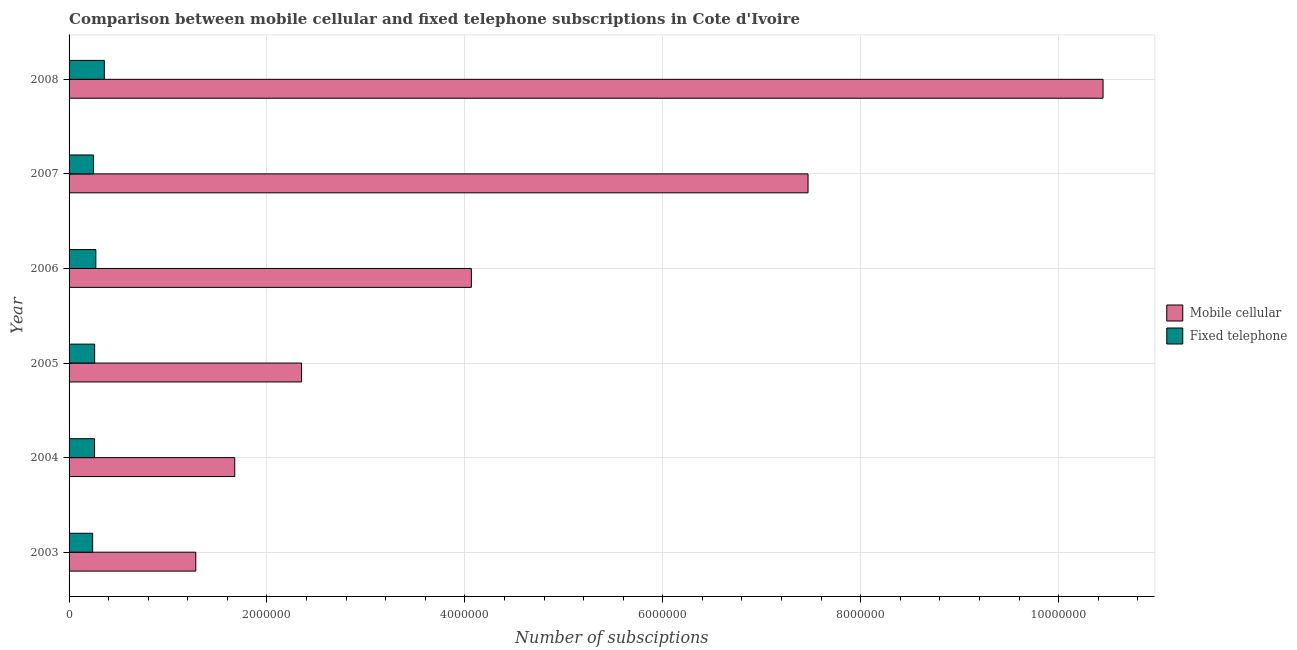How many groups of bars are there?
Give a very brief answer. 6. Are the number of bars per tick equal to the number of legend labels?
Your response must be concise. Yes. Are the number of bars on each tick of the Y-axis equal?
Offer a very short reply. Yes. How many bars are there on the 3rd tick from the top?
Provide a succinct answer. 2. How many bars are there on the 3rd tick from the bottom?
Give a very brief answer. 2. What is the number of mobile cellular subscriptions in 2004?
Make the answer very short. 1.67e+06. Across all years, what is the maximum number of fixed telephone subscriptions?
Offer a very short reply. 3.57e+05. Across all years, what is the minimum number of mobile cellular subscriptions?
Your answer should be compact. 1.28e+06. In which year was the number of fixed telephone subscriptions maximum?
Keep it short and to the point. 2008. What is the total number of fixed telephone subscriptions in the graph?
Offer a terse response. 1.63e+06. What is the difference between the number of mobile cellular subscriptions in 2007 and that in 2008?
Keep it short and to the point. -2.98e+06. What is the difference between the number of mobile cellular subscriptions in 2007 and the number of fixed telephone subscriptions in 2005?
Provide a succinct answer. 7.21e+06. What is the average number of fixed telephone subscriptions per year?
Ensure brevity in your answer.  2.72e+05. In the year 2008, what is the difference between the number of mobile cellular subscriptions and number of fixed telephone subscriptions?
Offer a very short reply. 1.01e+07. In how many years, is the number of mobile cellular subscriptions greater than 2400000 ?
Provide a short and direct response. 3. What is the ratio of the number of fixed telephone subscriptions in 2006 to that in 2007?
Your answer should be compact. 1.09. Is the number of fixed telephone subscriptions in 2006 less than that in 2007?
Give a very brief answer. No. What is the difference between the highest and the second highest number of mobile cellular subscriptions?
Provide a short and direct response. 2.98e+06. What is the difference between the highest and the lowest number of fixed telephone subscriptions?
Offer a very short reply. 1.19e+05. What does the 1st bar from the top in 2003 represents?
Make the answer very short. Fixed telephone. What does the 2nd bar from the bottom in 2008 represents?
Provide a short and direct response. Fixed telephone. How many bars are there?
Provide a succinct answer. 12. Are all the bars in the graph horizontal?
Offer a very short reply. Yes. How many years are there in the graph?
Your answer should be very brief. 6. Are the values on the major ticks of X-axis written in scientific E-notation?
Your answer should be very brief. No. Does the graph contain any zero values?
Your answer should be compact. No. How many legend labels are there?
Ensure brevity in your answer.  2. How are the legend labels stacked?
Your response must be concise. Vertical. What is the title of the graph?
Provide a succinct answer. Comparison between mobile cellular and fixed telephone subscriptions in Cote d'Ivoire. What is the label or title of the X-axis?
Offer a terse response. Number of subsciptions. What is the Number of subsciptions of Mobile cellular in 2003?
Provide a succinct answer. 1.28e+06. What is the Number of subsciptions of Fixed telephone in 2003?
Provide a short and direct response. 2.38e+05. What is the Number of subsciptions in Mobile cellular in 2004?
Your answer should be compact. 1.67e+06. What is the Number of subsciptions of Fixed telephone in 2004?
Provide a succinct answer. 2.58e+05. What is the Number of subsciptions in Mobile cellular in 2005?
Your answer should be compact. 2.35e+06. What is the Number of subsciptions of Fixed telephone in 2005?
Make the answer very short. 2.59e+05. What is the Number of subsciptions in Mobile cellular in 2006?
Offer a terse response. 4.07e+06. What is the Number of subsciptions in Fixed telephone in 2006?
Make the answer very short. 2.71e+05. What is the Number of subsciptions in Mobile cellular in 2007?
Offer a terse response. 7.47e+06. What is the Number of subsciptions in Fixed telephone in 2007?
Offer a terse response. 2.48e+05. What is the Number of subsciptions in Mobile cellular in 2008?
Provide a succinct answer. 1.04e+07. What is the Number of subsciptions in Fixed telephone in 2008?
Your answer should be compact. 3.57e+05. Across all years, what is the maximum Number of subsciptions of Mobile cellular?
Offer a terse response. 1.04e+07. Across all years, what is the maximum Number of subsciptions of Fixed telephone?
Give a very brief answer. 3.57e+05. Across all years, what is the minimum Number of subsciptions in Mobile cellular?
Give a very brief answer. 1.28e+06. Across all years, what is the minimum Number of subsciptions in Fixed telephone?
Offer a very short reply. 2.38e+05. What is the total Number of subsciptions of Mobile cellular in the graph?
Offer a very short reply. 2.73e+07. What is the total Number of subsciptions of Fixed telephone in the graph?
Your answer should be compact. 1.63e+06. What is the difference between the Number of subsciptions of Mobile cellular in 2003 and that in 2004?
Give a very brief answer. -3.94e+05. What is the difference between the Number of subsciptions in Fixed telephone in 2003 and that in 2004?
Your answer should be compact. -1.99e+04. What is the difference between the Number of subsciptions of Mobile cellular in 2003 and that in 2005?
Your answer should be very brief. -1.07e+06. What is the difference between the Number of subsciptions of Fixed telephone in 2003 and that in 2005?
Ensure brevity in your answer.  -2.05e+04. What is the difference between the Number of subsciptions of Mobile cellular in 2003 and that in 2006?
Offer a very short reply. -2.78e+06. What is the difference between the Number of subsciptions in Fixed telephone in 2003 and that in 2006?
Offer a very short reply. -3.26e+04. What is the difference between the Number of subsciptions of Mobile cellular in 2003 and that in 2007?
Make the answer very short. -6.19e+06. What is the difference between the Number of subsciptions in Fixed telephone in 2003 and that in 2007?
Your response must be concise. -9573. What is the difference between the Number of subsciptions in Mobile cellular in 2003 and that in 2008?
Offer a terse response. -9.17e+06. What is the difference between the Number of subsciptions of Fixed telephone in 2003 and that in 2008?
Provide a short and direct response. -1.19e+05. What is the difference between the Number of subsciptions of Mobile cellular in 2004 and that in 2005?
Offer a very short reply. -6.75e+05. What is the difference between the Number of subsciptions of Fixed telephone in 2004 and that in 2005?
Provide a succinct answer. -583. What is the difference between the Number of subsciptions in Mobile cellular in 2004 and that in 2006?
Provide a short and direct response. -2.39e+06. What is the difference between the Number of subsciptions of Fixed telephone in 2004 and that in 2006?
Give a very brief answer. -1.26e+04. What is the difference between the Number of subsciptions in Mobile cellular in 2004 and that in 2007?
Ensure brevity in your answer.  -5.79e+06. What is the difference between the Number of subsciptions in Fixed telephone in 2004 and that in 2007?
Ensure brevity in your answer.  1.04e+04. What is the difference between the Number of subsciptions in Mobile cellular in 2004 and that in 2008?
Your answer should be very brief. -8.77e+06. What is the difference between the Number of subsciptions in Fixed telephone in 2004 and that in 2008?
Your answer should be very brief. -9.86e+04. What is the difference between the Number of subsciptions of Mobile cellular in 2005 and that in 2006?
Offer a terse response. -1.72e+06. What is the difference between the Number of subsciptions in Fixed telephone in 2005 and that in 2006?
Offer a terse response. -1.21e+04. What is the difference between the Number of subsciptions in Mobile cellular in 2005 and that in 2007?
Offer a terse response. -5.12e+06. What is the difference between the Number of subsciptions in Fixed telephone in 2005 and that in 2007?
Ensure brevity in your answer.  1.09e+04. What is the difference between the Number of subsciptions of Mobile cellular in 2005 and that in 2008?
Your answer should be very brief. -8.10e+06. What is the difference between the Number of subsciptions of Fixed telephone in 2005 and that in 2008?
Offer a terse response. -9.80e+04. What is the difference between the Number of subsciptions of Mobile cellular in 2006 and that in 2007?
Your answer should be very brief. -3.40e+06. What is the difference between the Number of subsciptions of Fixed telephone in 2006 and that in 2007?
Offer a terse response. 2.30e+04. What is the difference between the Number of subsciptions of Mobile cellular in 2006 and that in 2008?
Provide a succinct answer. -6.38e+06. What is the difference between the Number of subsciptions in Fixed telephone in 2006 and that in 2008?
Your answer should be very brief. -8.59e+04. What is the difference between the Number of subsciptions in Mobile cellular in 2007 and that in 2008?
Offer a very short reply. -2.98e+06. What is the difference between the Number of subsciptions in Fixed telephone in 2007 and that in 2008?
Provide a short and direct response. -1.09e+05. What is the difference between the Number of subsciptions in Mobile cellular in 2003 and the Number of subsciptions in Fixed telephone in 2004?
Ensure brevity in your answer.  1.02e+06. What is the difference between the Number of subsciptions in Mobile cellular in 2003 and the Number of subsciptions in Fixed telephone in 2005?
Make the answer very short. 1.02e+06. What is the difference between the Number of subsciptions of Mobile cellular in 2003 and the Number of subsciptions of Fixed telephone in 2006?
Offer a terse response. 1.01e+06. What is the difference between the Number of subsciptions in Mobile cellular in 2003 and the Number of subsciptions in Fixed telephone in 2007?
Keep it short and to the point. 1.03e+06. What is the difference between the Number of subsciptions of Mobile cellular in 2003 and the Number of subsciptions of Fixed telephone in 2008?
Make the answer very short. 9.24e+05. What is the difference between the Number of subsciptions in Mobile cellular in 2004 and the Number of subsciptions in Fixed telephone in 2005?
Provide a succinct answer. 1.42e+06. What is the difference between the Number of subsciptions of Mobile cellular in 2004 and the Number of subsciptions of Fixed telephone in 2006?
Your answer should be very brief. 1.40e+06. What is the difference between the Number of subsciptions of Mobile cellular in 2004 and the Number of subsciptions of Fixed telephone in 2007?
Offer a terse response. 1.43e+06. What is the difference between the Number of subsciptions of Mobile cellular in 2004 and the Number of subsciptions of Fixed telephone in 2008?
Provide a succinct answer. 1.32e+06. What is the difference between the Number of subsciptions of Mobile cellular in 2005 and the Number of subsciptions of Fixed telephone in 2006?
Provide a short and direct response. 2.08e+06. What is the difference between the Number of subsciptions of Mobile cellular in 2005 and the Number of subsciptions of Fixed telephone in 2007?
Make the answer very short. 2.10e+06. What is the difference between the Number of subsciptions of Mobile cellular in 2005 and the Number of subsciptions of Fixed telephone in 2008?
Your response must be concise. 1.99e+06. What is the difference between the Number of subsciptions of Mobile cellular in 2006 and the Number of subsciptions of Fixed telephone in 2007?
Your answer should be compact. 3.82e+06. What is the difference between the Number of subsciptions in Mobile cellular in 2006 and the Number of subsciptions in Fixed telephone in 2008?
Make the answer very short. 3.71e+06. What is the difference between the Number of subsciptions in Mobile cellular in 2007 and the Number of subsciptions in Fixed telephone in 2008?
Provide a short and direct response. 7.11e+06. What is the average Number of subsciptions in Mobile cellular per year?
Offer a terse response. 4.55e+06. What is the average Number of subsciptions of Fixed telephone per year?
Keep it short and to the point. 2.72e+05. In the year 2003, what is the difference between the Number of subsciptions of Mobile cellular and Number of subsciptions of Fixed telephone?
Offer a terse response. 1.04e+06. In the year 2004, what is the difference between the Number of subsciptions in Mobile cellular and Number of subsciptions in Fixed telephone?
Make the answer very short. 1.42e+06. In the year 2005, what is the difference between the Number of subsciptions in Mobile cellular and Number of subsciptions in Fixed telephone?
Make the answer very short. 2.09e+06. In the year 2006, what is the difference between the Number of subsciptions of Mobile cellular and Number of subsciptions of Fixed telephone?
Offer a terse response. 3.79e+06. In the year 2007, what is the difference between the Number of subsciptions in Mobile cellular and Number of subsciptions in Fixed telephone?
Give a very brief answer. 7.22e+06. In the year 2008, what is the difference between the Number of subsciptions in Mobile cellular and Number of subsciptions in Fixed telephone?
Offer a terse response. 1.01e+07. What is the ratio of the Number of subsciptions in Mobile cellular in 2003 to that in 2004?
Provide a succinct answer. 0.76. What is the ratio of the Number of subsciptions of Fixed telephone in 2003 to that in 2004?
Provide a short and direct response. 0.92. What is the ratio of the Number of subsciptions of Mobile cellular in 2003 to that in 2005?
Offer a very short reply. 0.55. What is the ratio of the Number of subsciptions of Fixed telephone in 2003 to that in 2005?
Provide a short and direct response. 0.92. What is the ratio of the Number of subsciptions in Mobile cellular in 2003 to that in 2006?
Ensure brevity in your answer.  0.32. What is the ratio of the Number of subsciptions of Fixed telephone in 2003 to that in 2006?
Provide a succinct answer. 0.88. What is the ratio of the Number of subsciptions in Mobile cellular in 2003 to that in 2007?
Your answer should be compact. 0.17. What is the ratio of the Number of subsciptions in Fixed telephone in 2003 to that in 2007?
Provide a short and direct response. 0.96. What is the ratio of the Number of subsciptions of Mobile cellular in 2003 to that in 2008?
Ensure brevity in your answer.  0.12. What is the ratio of the Number of subsciptions in Fixed telephone in 2003 to that in 2008?
Offer a very short reply. 0.67. What is the ratio of the Number of subsciptions in Mobile cellular in 2004 to that in 2005?
Keep it short and to the point. 0.71. What is the ratio of the Number of subsciptions of Fixed telephone in 2004 to that in 2005?
Offer a terse response. 1. What is the ratio of the Number of subsciptions of Mobile cellular in 2004 to that in 2006?
Provide a succinct answer. 0.41. What is the ratio of the Number of subsciptions of Fixed telephone in 2004 to that in 2006?
Your response must be concise. 0.95. What is the ratio of the Number of subsciptions in Mobile cellular in 2004 to that in 2007?
Your response must be concise. 0.22. What is the ratio of the Number of subsciptions of Fixed telephone in 2004 to that in 2007?
Keep it short and to the point. 1.04. What is the ratio of the Number of subsciptions in Mobile cellular in 2004 to that in 2008?
Make the answer very short. 0.16. What is the ratio of the Number of subsciptions in Fixed telephone in 2004 to that in 2008?
Ensure brevity in your answer.  0.72. What is the ratio of the Number of subsciptions in Mobile cellular in 2005 to that in 2006?
Keep it short and to the point. 0.58. What is the ratio of the Number of subsciptions in Fixed telephone in 2005 to that in 2006?
Provide a short and direct response. 0.96. What is the ratio of the Number of subsciptions in Mobile cellular in 2005 to that in 2007?
Your answer should be compact. 0.31. What is the ratio of the Number of subsciptions in Fixed telephone in 2005 to that in 2007?
Provide a short and direct response. 1.04. What is the ratio of the Number of subsciptions of Mobile cellular in 2005 to that in 2008?
Your response must be concise. 0.22. What is the ratio of the Number of subsciptions of Fixed telephone in 2005 to that in 2008?
Your response must be concise. 0.73. What is the ratio of the Number of subsciptions of Mobile cellular in 2006 to that in 2007?
Provide a short and direct response. 0.54. What is the ratio of the Number of subsciptions in Fixed telephone in 2006 to that in 2007?
Your response must be concise. 1.09. What is the ratio of the Number of subsciptions in Mobile cellular in 2006 to that in 2008?
Offer a terse response. 0.39. What is the ratio of the Number of subsciptions of Fixed telephone in 2006 to that in 2008?
Offer a terse response. 0.76. What is the ratio of the Number of subsciptions in Mobile cellular in 2007 to that in 2008?
Keep it short and to the point. 0.71. What is the ratio of the Number of subsciptions in Fixed telephone in 2007 to that in 2008?
Make the answer very short. 0.69. What is the difference between the highest and the second highest Number of subsciptions in Mobile cellular?
Ensure brevity in your answer.  2.98e+06. What is the difference between the highest and the second highest Number of subsciptions in Fixed telephone?
Your response must be concise. 8.59e+04. What is the difference between the highest and the lowest Number of subsciptions of Mobile cellular?
Make the answer very short. 9.17e+06. What is the difference between the highest and the lowest Number of subsciptions in Fixed telephone?
Your response must be concise. 1.19e+05. 